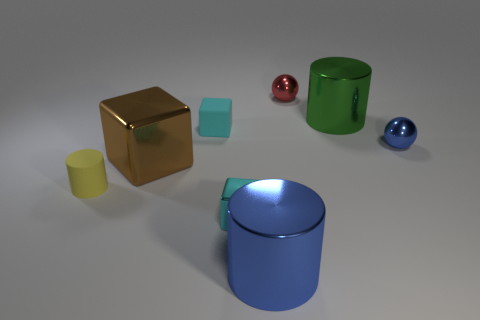Subtract all tiny blocks. How many blocks are left? 1 Subtract all brown blocks. How many blocks are left? 2 Add 2 blue spheres. How many objects exist? 10 Subtract all purple cylinders. How many cyan blocks are left? 2 Subtract 1 cubes. How many cubes are left? 2 Subtract all blocks. How many objects are left? 5 Subtract all purple cylinders. Subtract all yellow balls. How many cylinders are left? 3 Subtract all cyan metal objects. Subtract all big cyan matte cylinders. How many objects are left? 7 Add 6 large green shiny objects. How many large green shiny objects are left? 7 Add 2 yellow matte things. How many yellow matte things exist? 3 